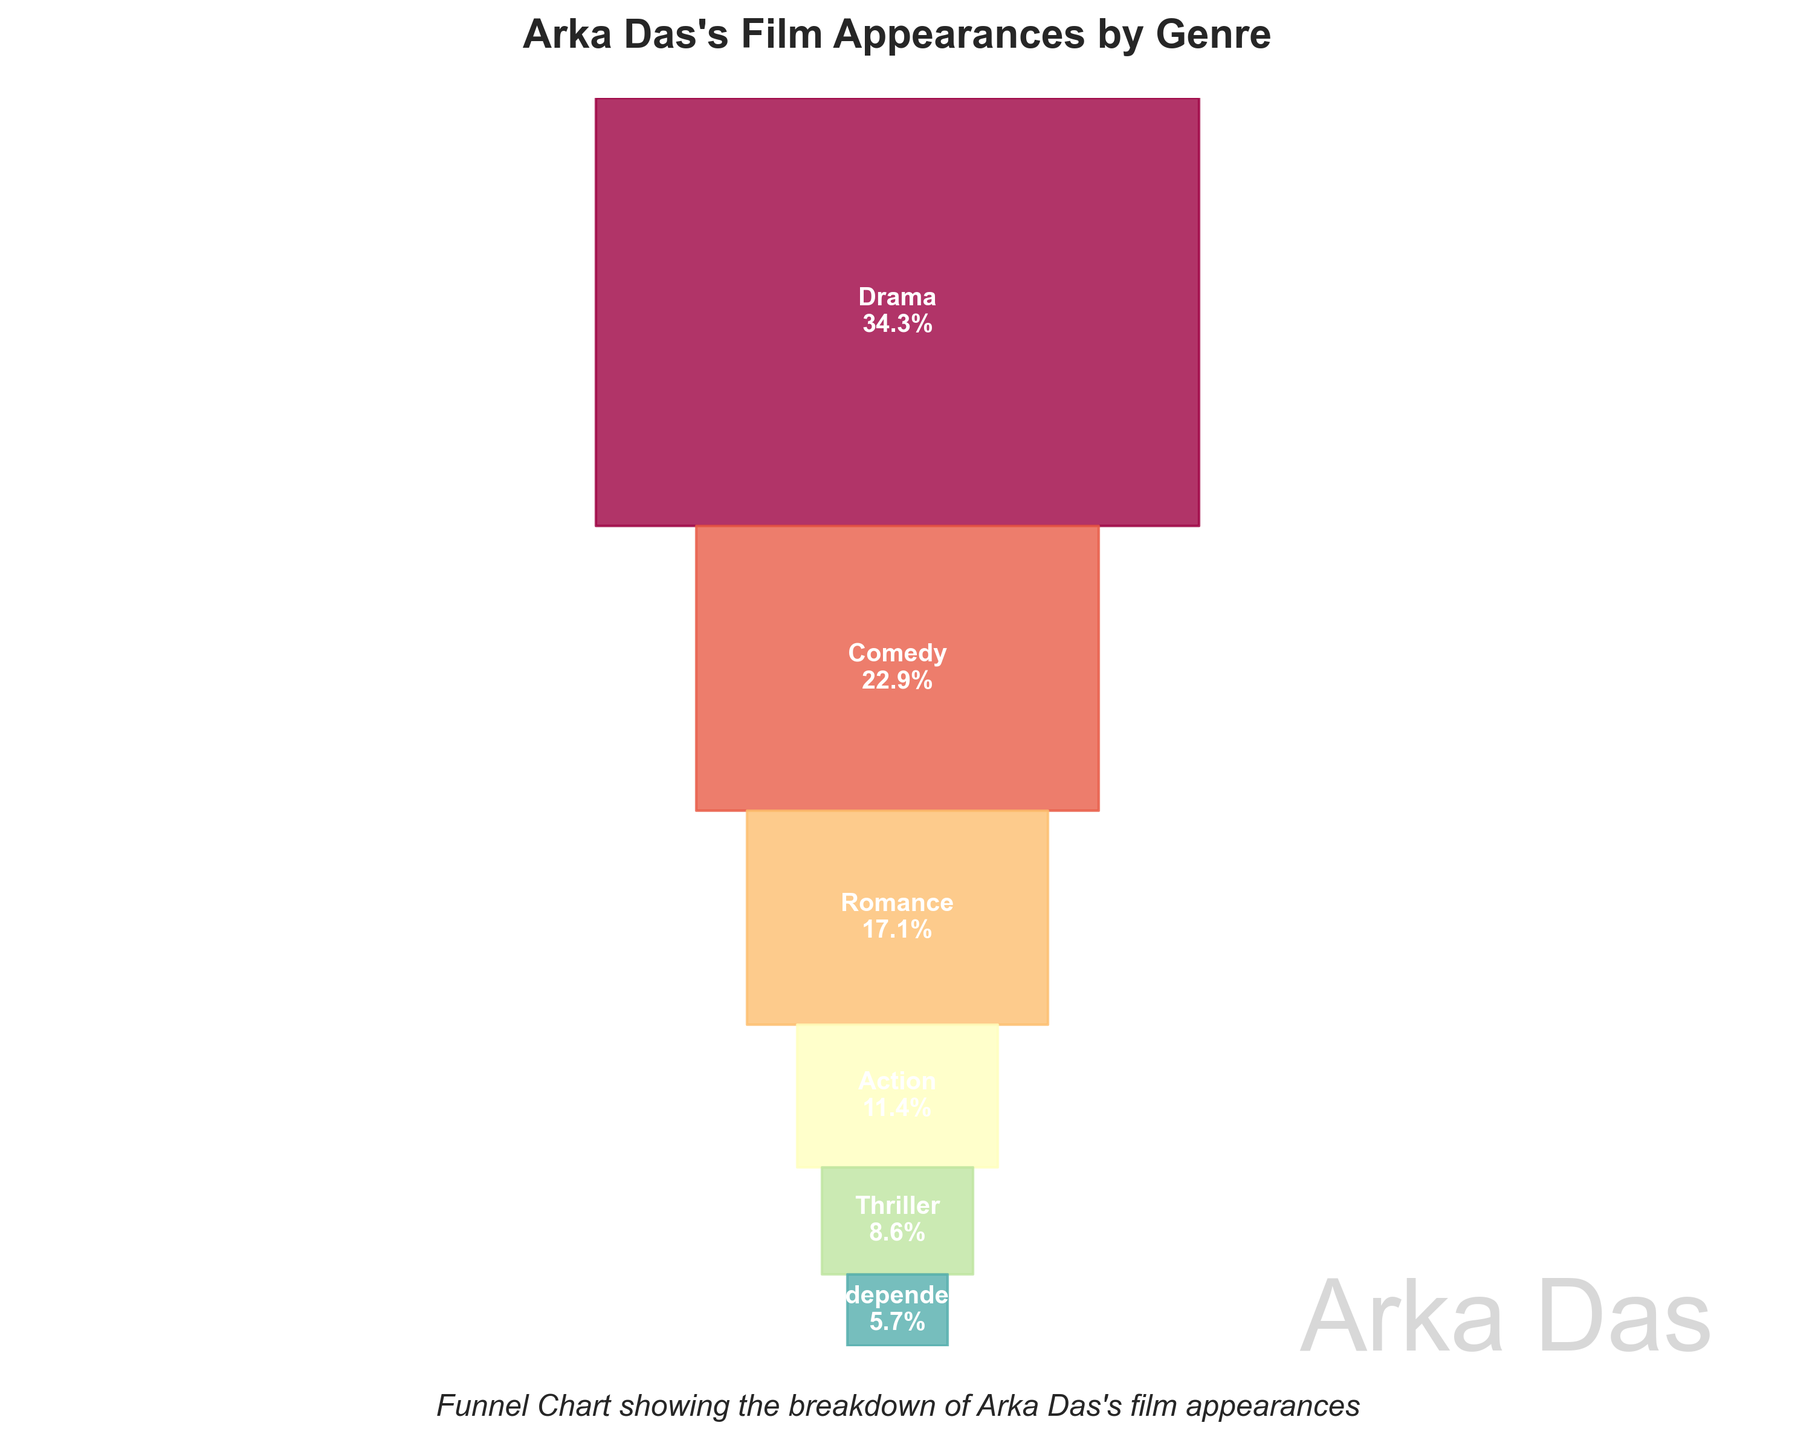What genre has the highest number of appearances? By looking at the funnel chart, the widest segment represents the genre with the highest appearances. The label inside the widest segment indicates it.
Answer: Drama How many genres are represented in the chart? Count the number of separate segments with genre labels in the funnel chart.
Answer: 6 What percentage of Arka Das's films are Comedies? Find the segment labeled "Comedy" and read the percentage value next to it.
Answer: 20% Which genre has the least number of appearances? The narrowest segment represents the genre with the least appearances. The label inside the narrowest segment indicates it.
Answer: Independent How many more Drama appearances are there compared to Action appearances? Find the number of appearances for Drama and Action from the funnel chart and subtract the number of Action appearances from Drama appearances.
Answer: 8 What is the combined percentage of Romance and Thriller films? Add the percentages for the Romance and Thriller segments.
Answer: 15% What is the cumulative percentage up to the Genre "Romance"? Sum the percentages of Drama, Comedy, and Romance. The cumulative percentage is obtained by adding 30%, 20%, and 15%.
Answer: 65% Which genres contribute to more than 10% of Arka Das's filmography? Look for all segments in the funnel chart where the percentage is greater than 10%. These are Drama, Comedy, and Romance.
Answer: Drama, Comedy, Romance Is the percentage of Action films less than half the percentage of Comedy films? Compare the percentage of Action films with half of the percentage of Comedy films. Half of Comedy's 20% is 10%, and Action is 10%, which is equal to half, not less.
Answer: No What percentage of Arka Das's films are categorized as Independent films? Find the segment labeled "Independent" and read the percentage value next to it.
Answer: 5% 